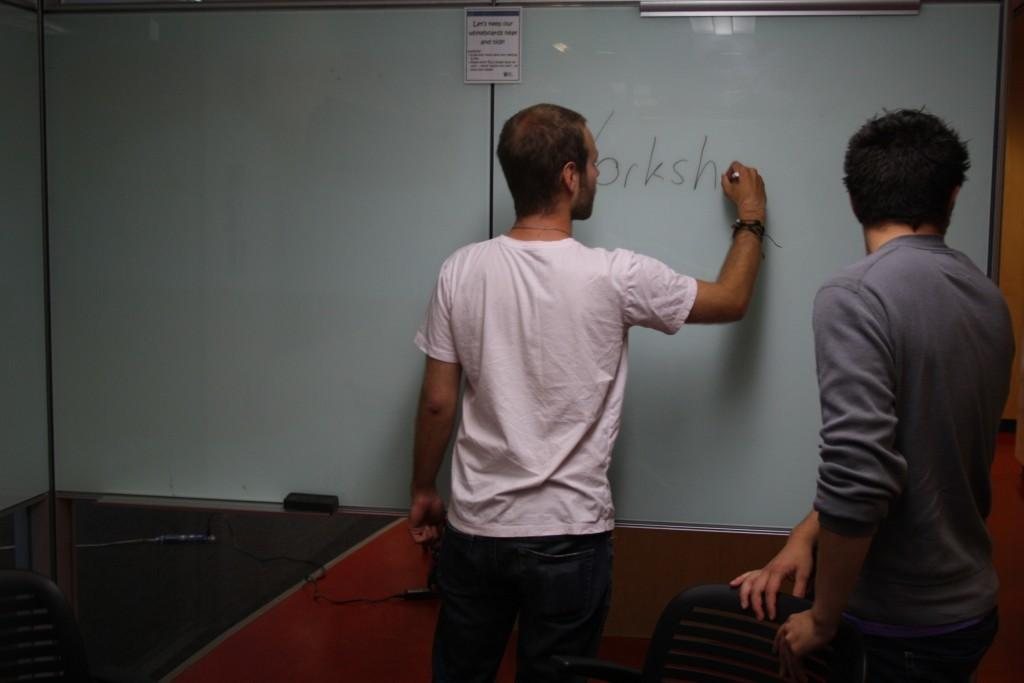<image>
Give a short and clear explanation of the subsequent image. One man has written the letters Yorksh on a white board while another stands behind him. 